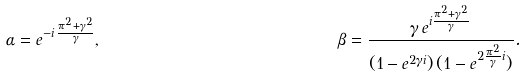Convert formula to latex. <formula><loc_0><loc_0><loc_500><loc_500>\alpha & = e ^ { - i \, \frac { \pi ^ { 2 } + \gamma ^ { 2 } } { \gamma } } , & \beta & = \frac { \gamma \, e ^ { i \frac { \pi ^ { 2 } + \gamma ^ { 2 } } { \gamma } } } { ( 1 - e ^ { 2 \gamma i } ) \, ( 1 - e ^ { 2 \frac { \pi ^ { 2 } } { \gamma } i } ) } .</formula> 